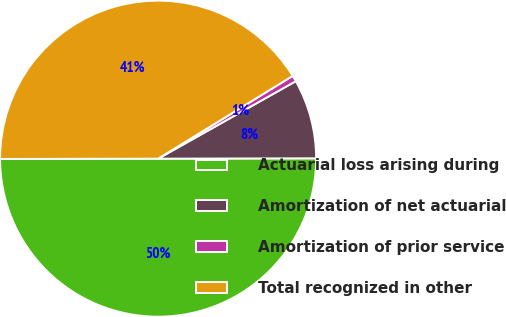<chart> <loc_0><loc_0><loc_500><loc_500><pie_chart><fcel>Actuarial loss arising during<fcel>Amortization of net actuarial<fcel>Amortization of prior service<fcel>Total recognized in other<nl><fcel>50.0%<fcel>8.12%<fcel>0.62%<fcel>41.25%<nl></chart> 